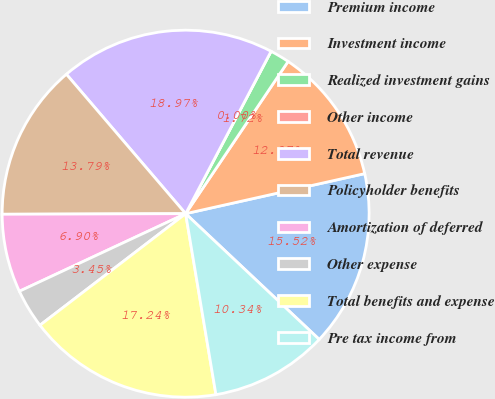Convert chart to OTSL. <chart><loc_0><loc_0><loc_500><loc_500><pie_chart><fcel>Premium income<fcel>Investment income<fcel>Realized investment gains<fcel>Other income<fcel>Total revenue<fcel>Policyholder benefits<fcel>Amortization of deferred<fcel>Other expense<fcel>Total benefits and expense<fcel>Pre tax income from<nl><fcel>15.52%<fcel>12.07%<fcel>1.72%<fcel>0.0%<fcel>18.97%<fcel>13.79%<fcel>6.9%<fcel>3.45%<fcel>17.24%<fcel>10.34%<nl></chart> 